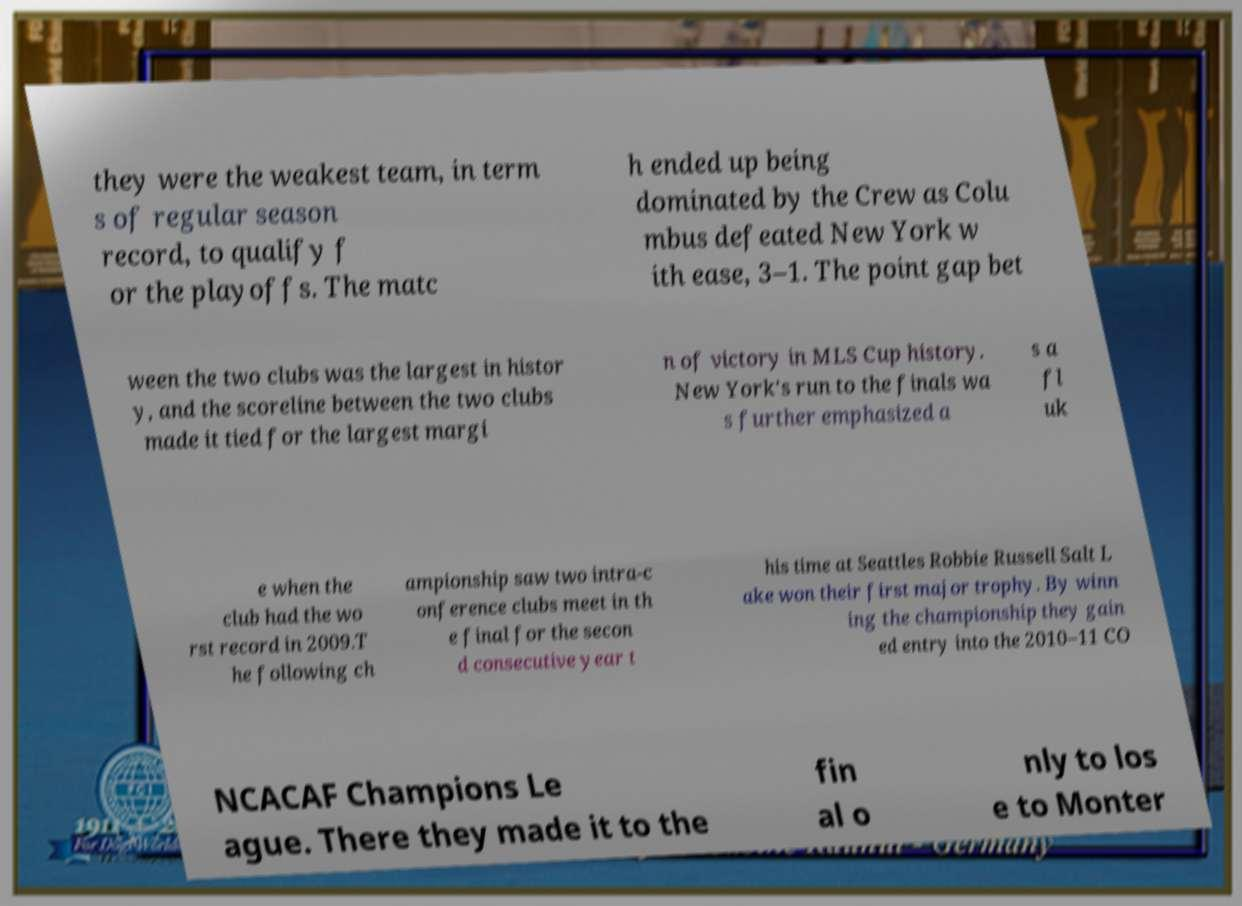Can you accurately transcribe the text from the provided image for me? they were the weakest team, in term s of regular season record, to qualify f or the playoffs. The matc h ended up being dominated by the Crew as Colu mbus defeated New York w ith ease, 3–1. The point gap bet ween the two clubs was the largest in histor y, and the scoreline between the two clubs made it tied for the largest margi n of victory in MLS Cup history. New York's run to the finals wa s further emphasized a s a fl uk e when the club had the wo rst record in 2009.T he following ch ampionship saw two intra-c onference clubs meet in th e final for the secon d consecutive year t his time at Seattles Robbie Russell Salt L ake won their first major trophy. By winn ing the championship they gain ed entry into the 2010–11 CO NCACAF Champions Le ague. There they made it to the fin al o nly to los e to Monter 